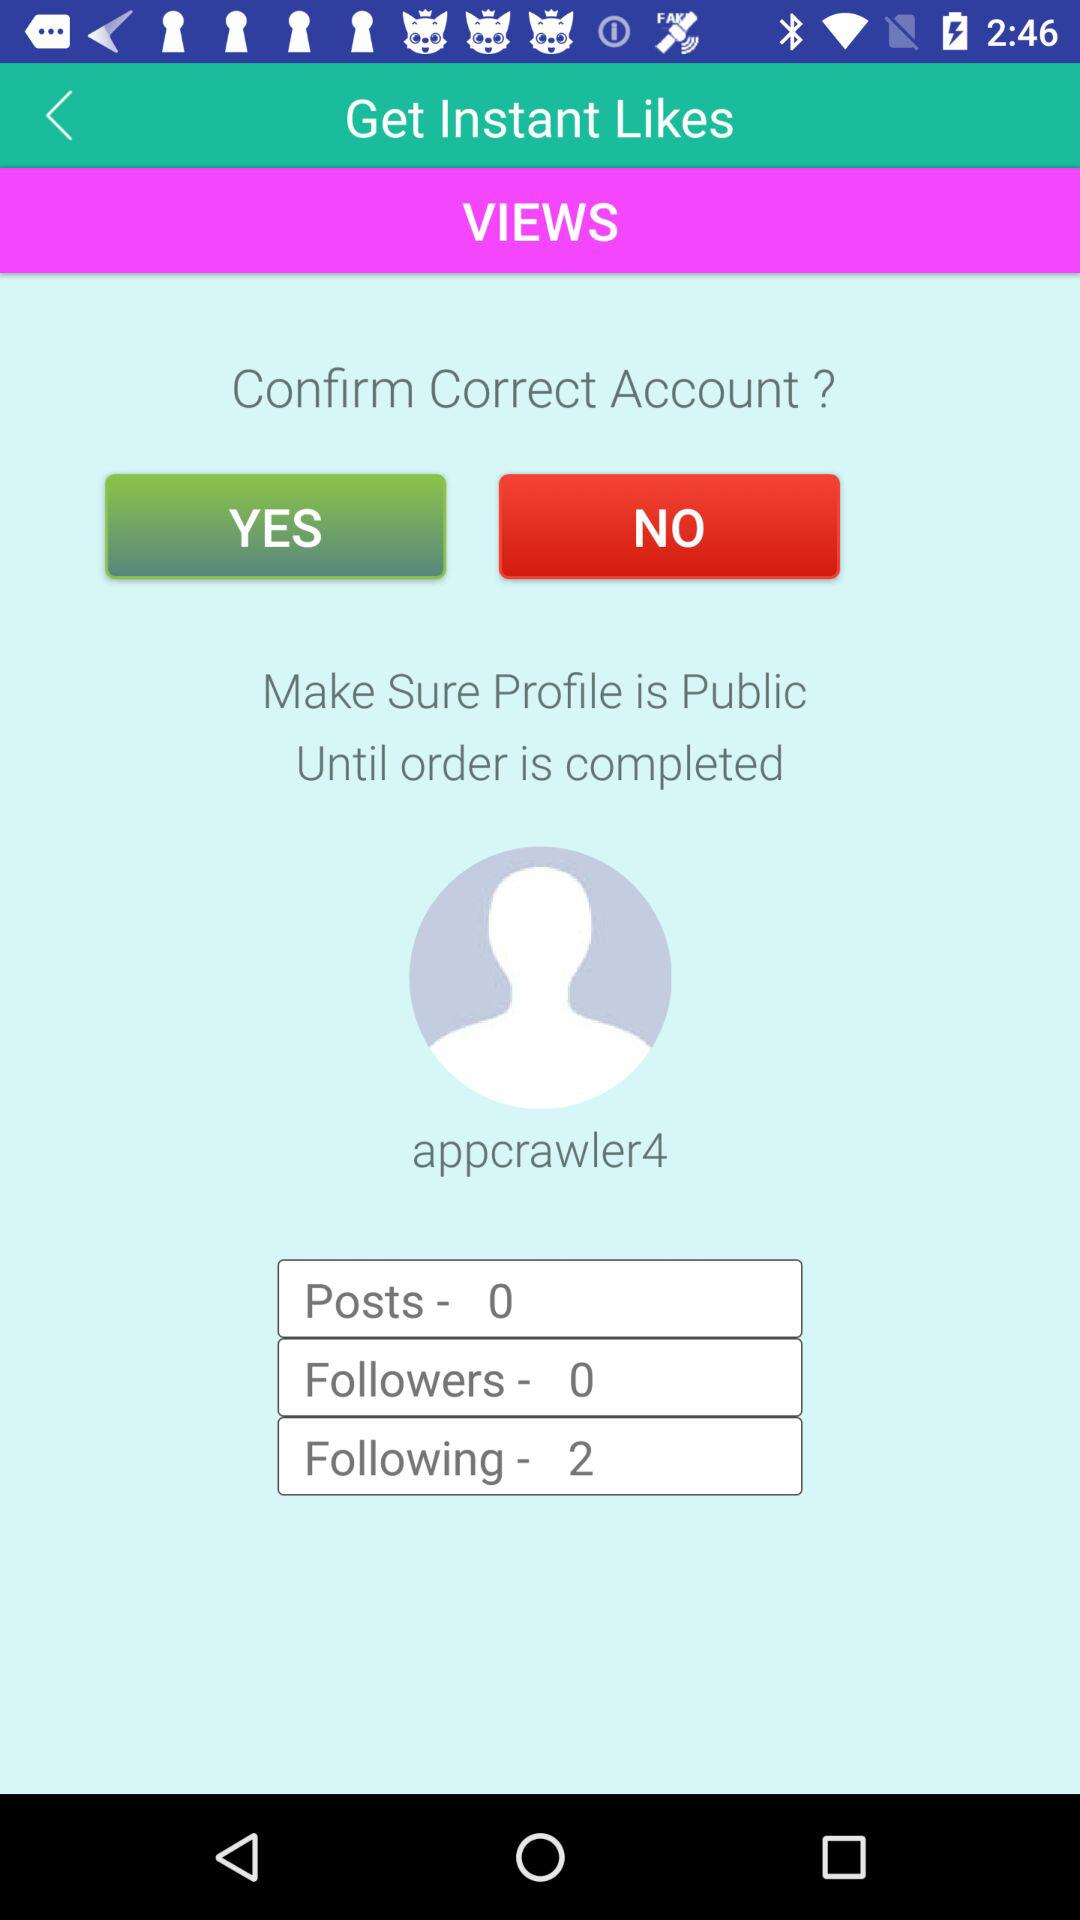How many posts are there? There are 0 posts. 